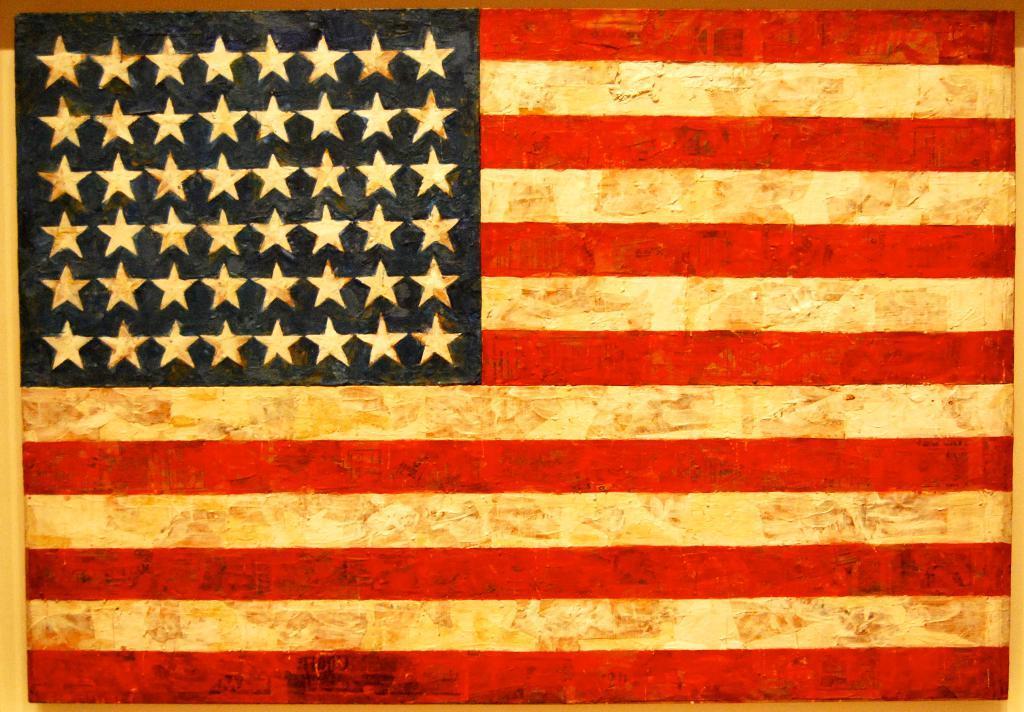Can you describe this image briefly? In this image we can see the paint of a flag on the wooden surface. 